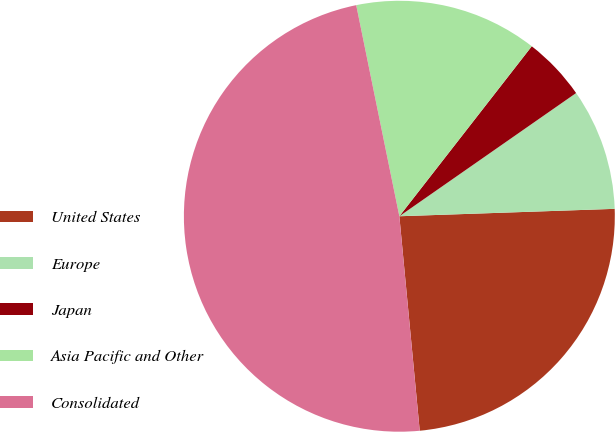<chart> <loc_0><loc_0><loc_500><loc_500><pie_chart><fcel>United States<fcel>Europe<fcel>Japan<fcel>Asia Pacific and Other<fcel>Consolidated<nl><fcel>24.04%<fcel>9.14%<fcel>4.78%<fcel>13.74%<fcel>48.3%<nl></chart> 